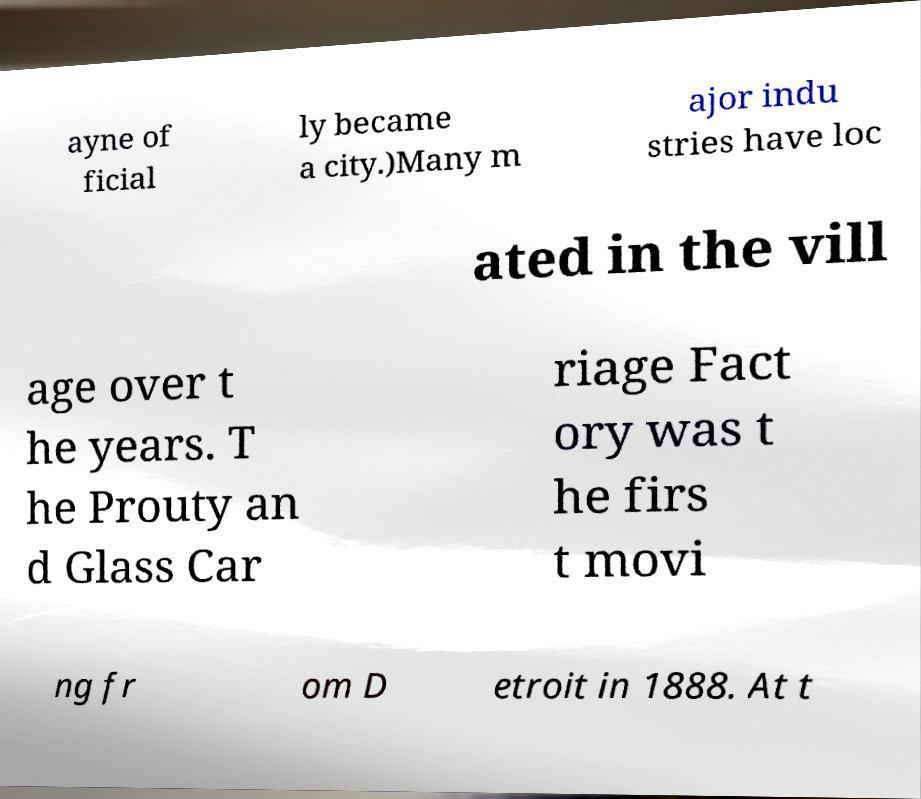Please read and relay the text visible in this image. What does it say? ayne of ficial ly became a city.)Many m ajor indu stries have loc ated in the vill age over t he years. T he Prouty an d Glass Car riage Fact ory was t he firs t movi ng fr om D etroit in 1888. At t 